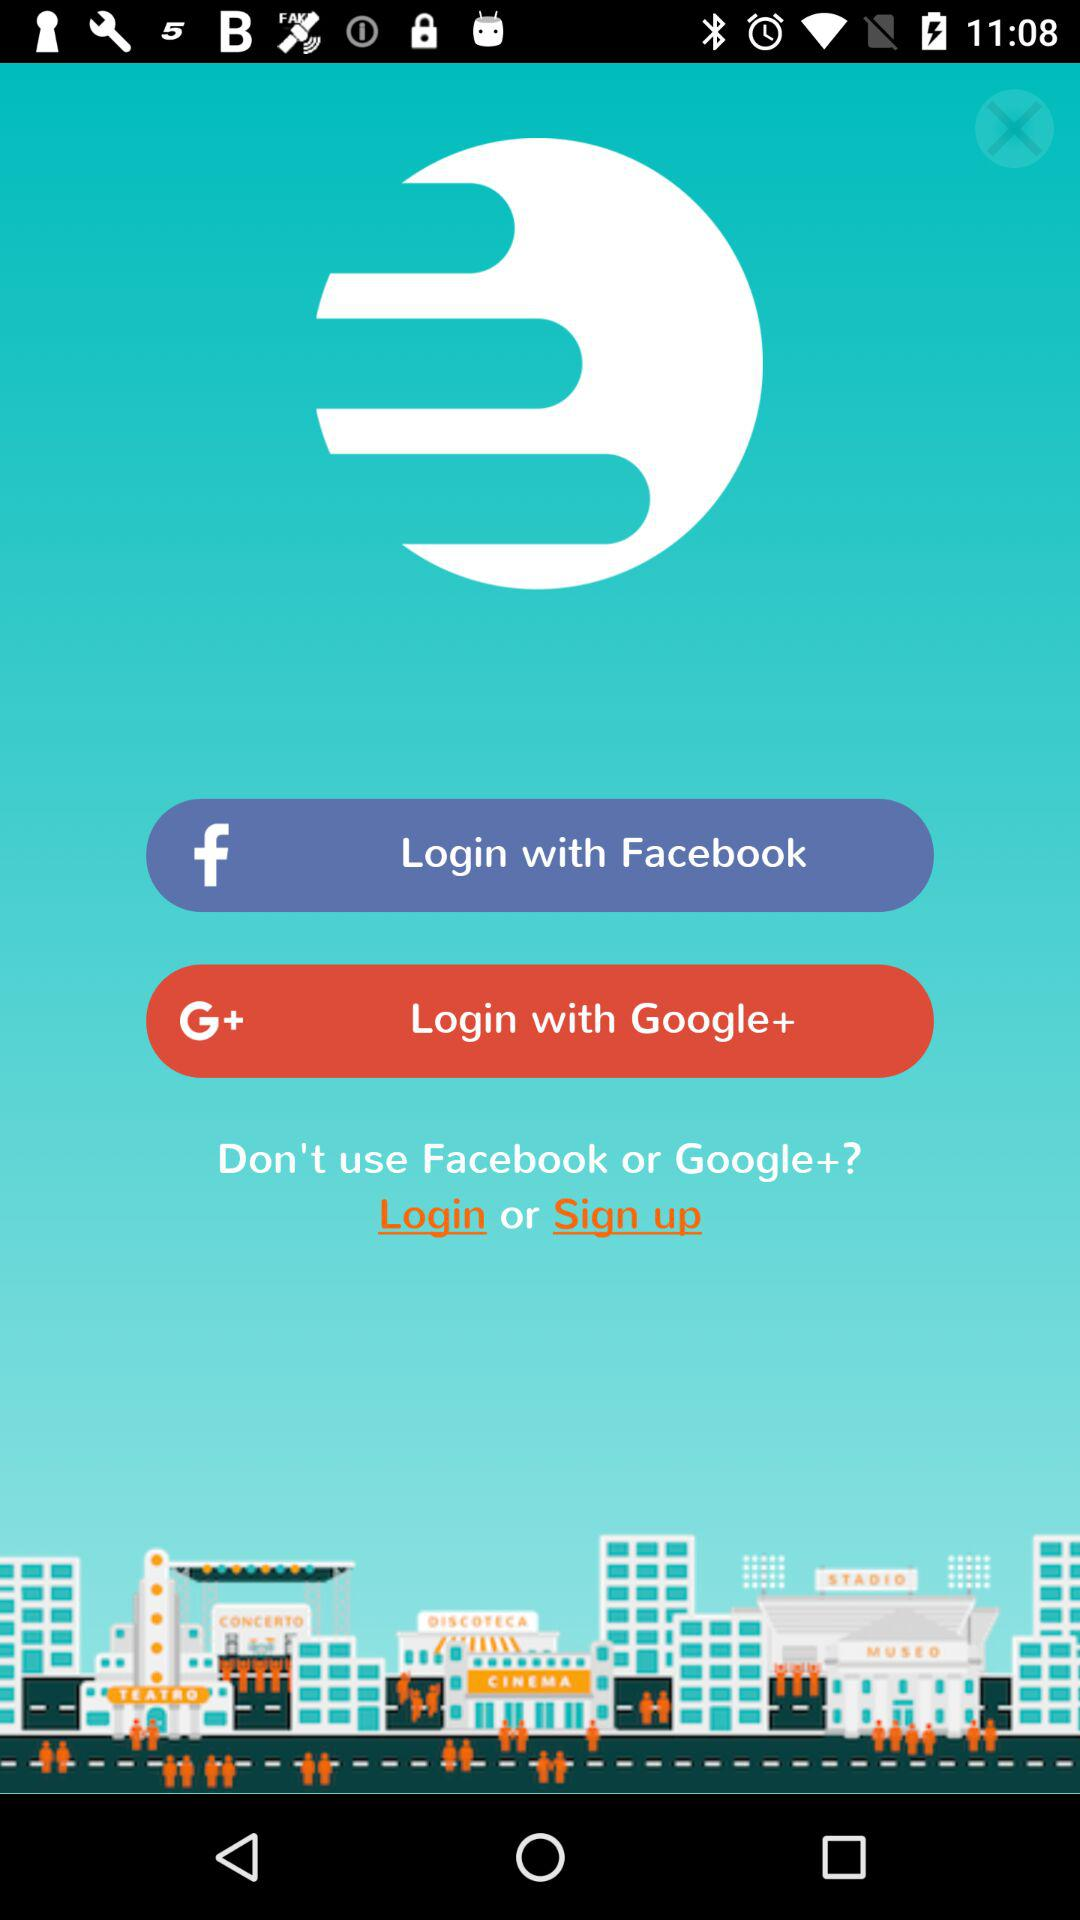What accounts can I use to login? The accounts you can use to login are "Facebook" and "Google+". 